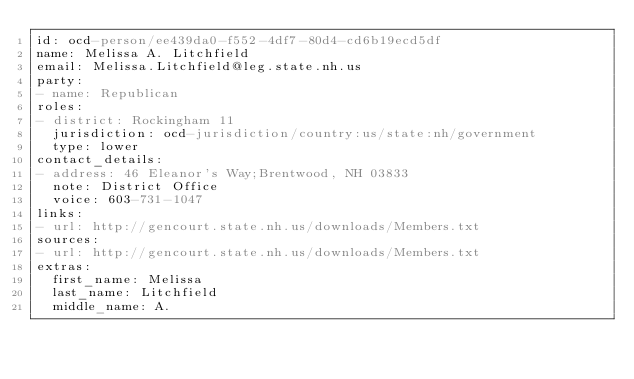<code> <loc_0><loc_0><loc_500><loc_500><_YAML_>id: ocd-person/ee439da0-f552-4df7-80d4-cd6b19ecd5df
name: Melissa A. Litchfield
email: Melissa.Litchfield@leg.state.nh.us
party:
- name: Republican
roles:
- district: Rockingham 11
  jurisdiction: ocd-jurisdiction/country:us/state:nh/government
  type: lower
contact_details:
- address: 46 Eleanor's Way;Brentwood, NH 03833
  note: District Office
  voice: 603-731-1047
links:
- url: http://gencourt.state.nh.us/downloads/Members.txt
sources:
- url: http://gencourt.state.nh.us/downloads/Members.txt
extras:
  first_name: Melissa
  last_name: Litchfield
  middle_name: A.
</code> 